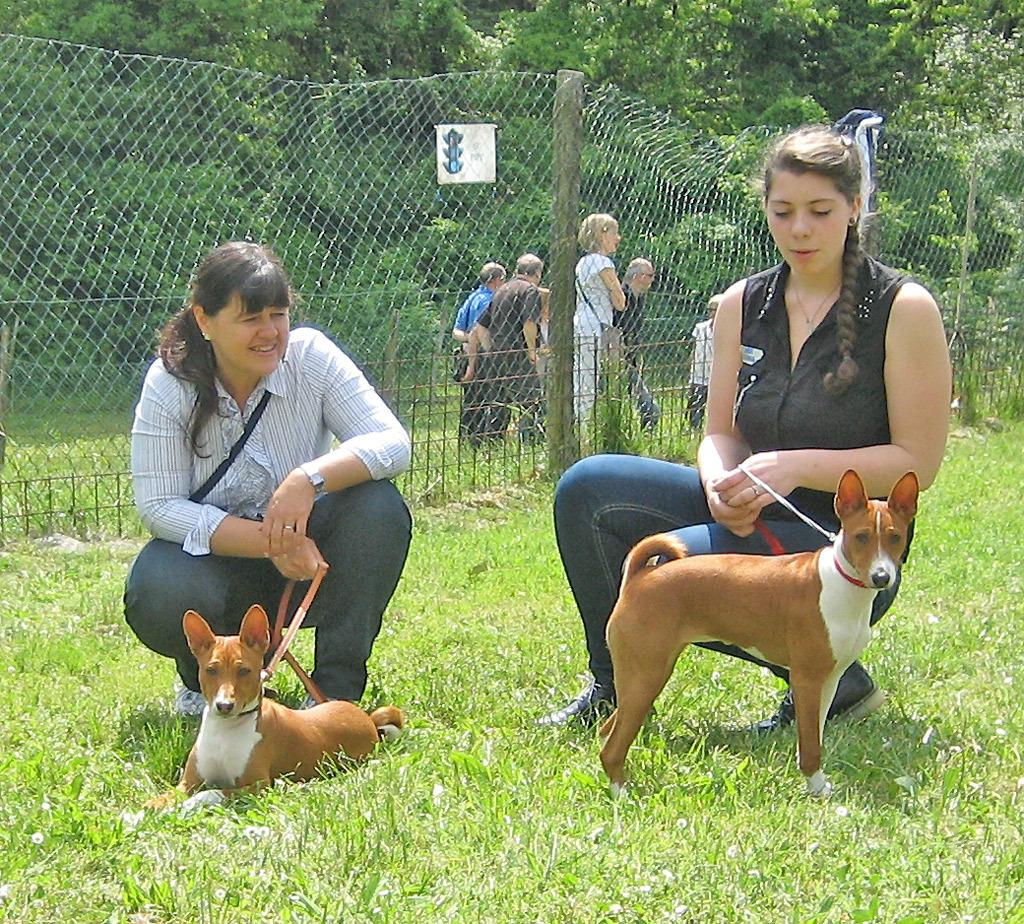How many people are in the image? There are people in the image, but the exact number is not specified. What are the people holding in the image? Two people are holding dog leashes in the image. What type of vegetation is present in the image? There are trees and grass in the image. What type of barrier is visible in the image? There is a fence in the image. What flavor of ice cream is being offered to the dog in the image? There is no ice cream or dog present in the image, so it is not possible to determine the flavor being offered. 